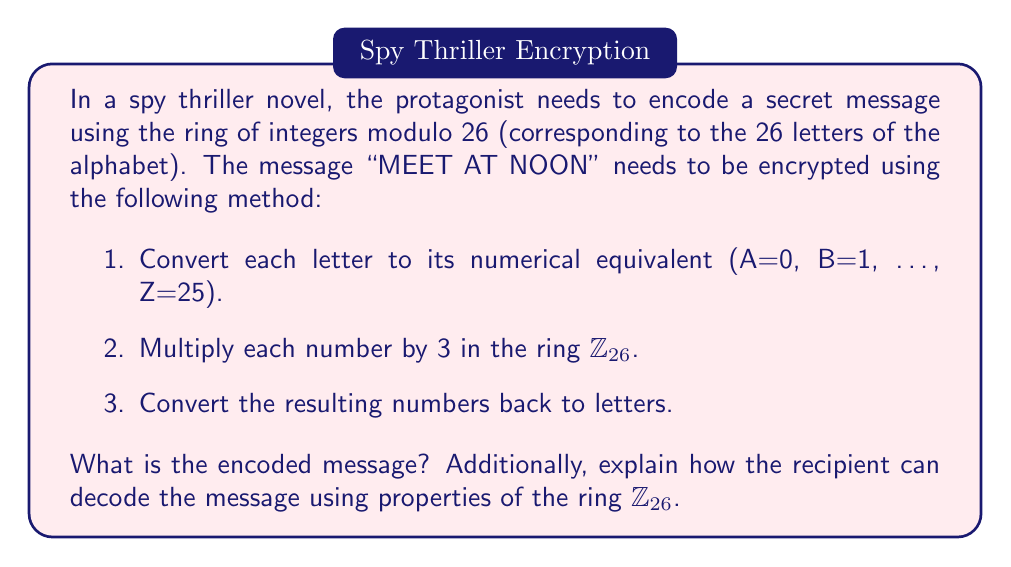Can you solve this math problem? Let's approach this step-by-step:

1. First, we convert the message to numbers:
   M E E T   A T   N O O N
   12 4 4 19 0 19 13 14 14 13

2. Now, we multiply each number by 3 in $\mathbb{Z}_{26}$. This means we perform the multiplication and then take the result modulo 26:

   $12 \cdot 3 \equiv 10 \pmod{26}$
   $4 \cdot 3 \equiv 12 \pmod{26}$
   $4 \cdot 3 \equiv 12 \pmod{26}$
   $19 \cdot 3 \equiv 5 \pmod{26}$
   $0 \cdot 3 \equiv 0 \pmod{26}$
   $19 \cdot 3 \equiv 5 \pmod{26}$
   $13 \cdot 3 \equiv 13 \pmod{26}$
   $14 \cdot 3 \equiv 16 \pmod{26}$
   $14 \cdot 3 \equiv 16 \pmod{26}$
   $13 \cdot 3 \equiv 13 \pmod{26}$

3. Converting back to letters:
   10 12 12 5 0 5 13 16 16 13
   K  M  M  F A F N  Q  Q  N

So the encoded message is "KMMFAFNQQN".

To decode the message, the recipient needs to find the multiplicative inverse of 3 in $\mathbb{Z}_{26}$. This is a number $x$ such that $3x \equiv 1 \pmod{26}$.

We can find this by solving the congruence:
$3x \equiv 1 \pmod{26}$

One way to solve this is to use the extended Euclidean algorithm. Alternatively, we can observe that $3 \cdot 9 = 27 \equiv 1 \pmod{26}$.

Therefore, the multiplicative inverse of 3 in $\mathbb{Z}_{26}$ is 9.

To decode, the recipient would multiply each number by 9 in $\mathbb{Z}_{26}$:

$10 \cdot 9 \equiv 12 \pmod{26}$
$12 \cdot 9 \equiv 4 \pmod{26}$
...and so on.

This process will recover the original message.
Answer: The encoded message is "KMMFAFNQQN". To decode, multiply each letter's numerical equivalent by 9 in $\mathbb{Z}_{26}$. 